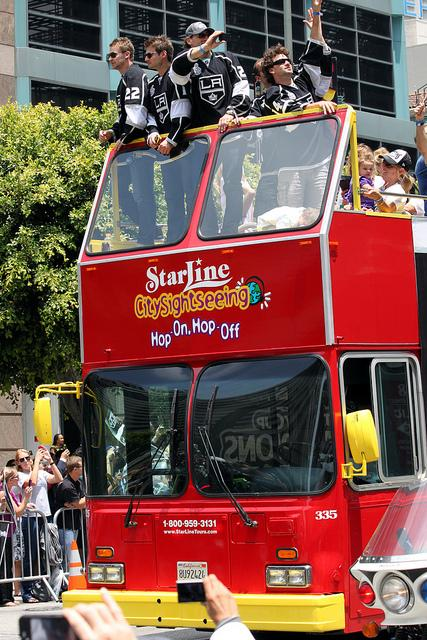The person on the motorcycle escorting the double decker bus is what type of public servant? Please explain your reasoning. policeman. The person is a policeman since he's wearing an officer uniform. 